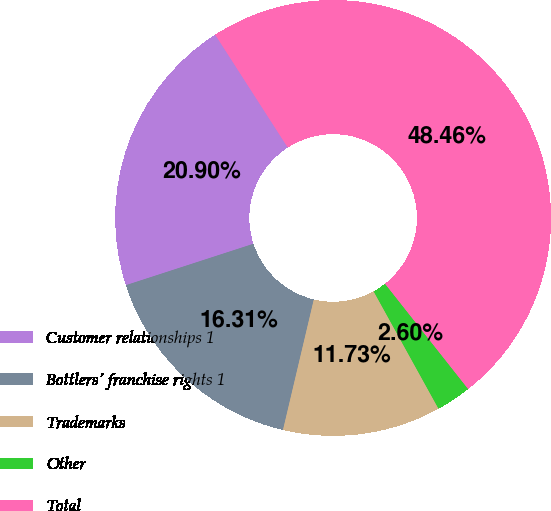<chart> <loc_0><loc_0><loc_500><loc_500><pie_chart><fcel>Customer relationships 1<fcel>Bottlers' franchise rights 1<fcel>Trademarks<fcel>Other<fcel>Total<nl><fcel>20.9%<fcel>16.31%<fcel>11.73%<fcel>2.6%<fcel>48.46%<nl></chart> 